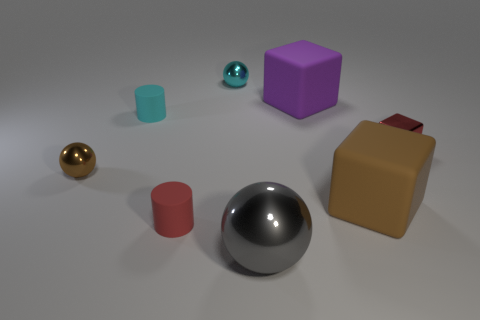Add 1 metal spheres. How many objects exist? 9 Subtract all balls. How many objects are left? 5 Add 5 large brown rubber things. How many large brown rubber things exist? 6 Subtract 0 gray cylinders. How many objects are left? 8 Subtract all gray metallic spheres. Subtract all brown things. How many objects are left? 5 Add 2 shiny balls. How many shiny balls are left? 5 